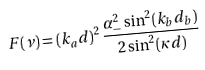Convert formula to latex. <formula><loc_0><loc_0><loc_500><loc_500>F ( \nu ) = ( k _ { a } d ) ^ { 2 } \, \frac { \alpha _ { - } ^ { 2 } \sin ^ { 2 } ( k _ { b } d _ { b } ) } { 2 \sin ^ { 2 } ( \kappa d ) }</formula> 